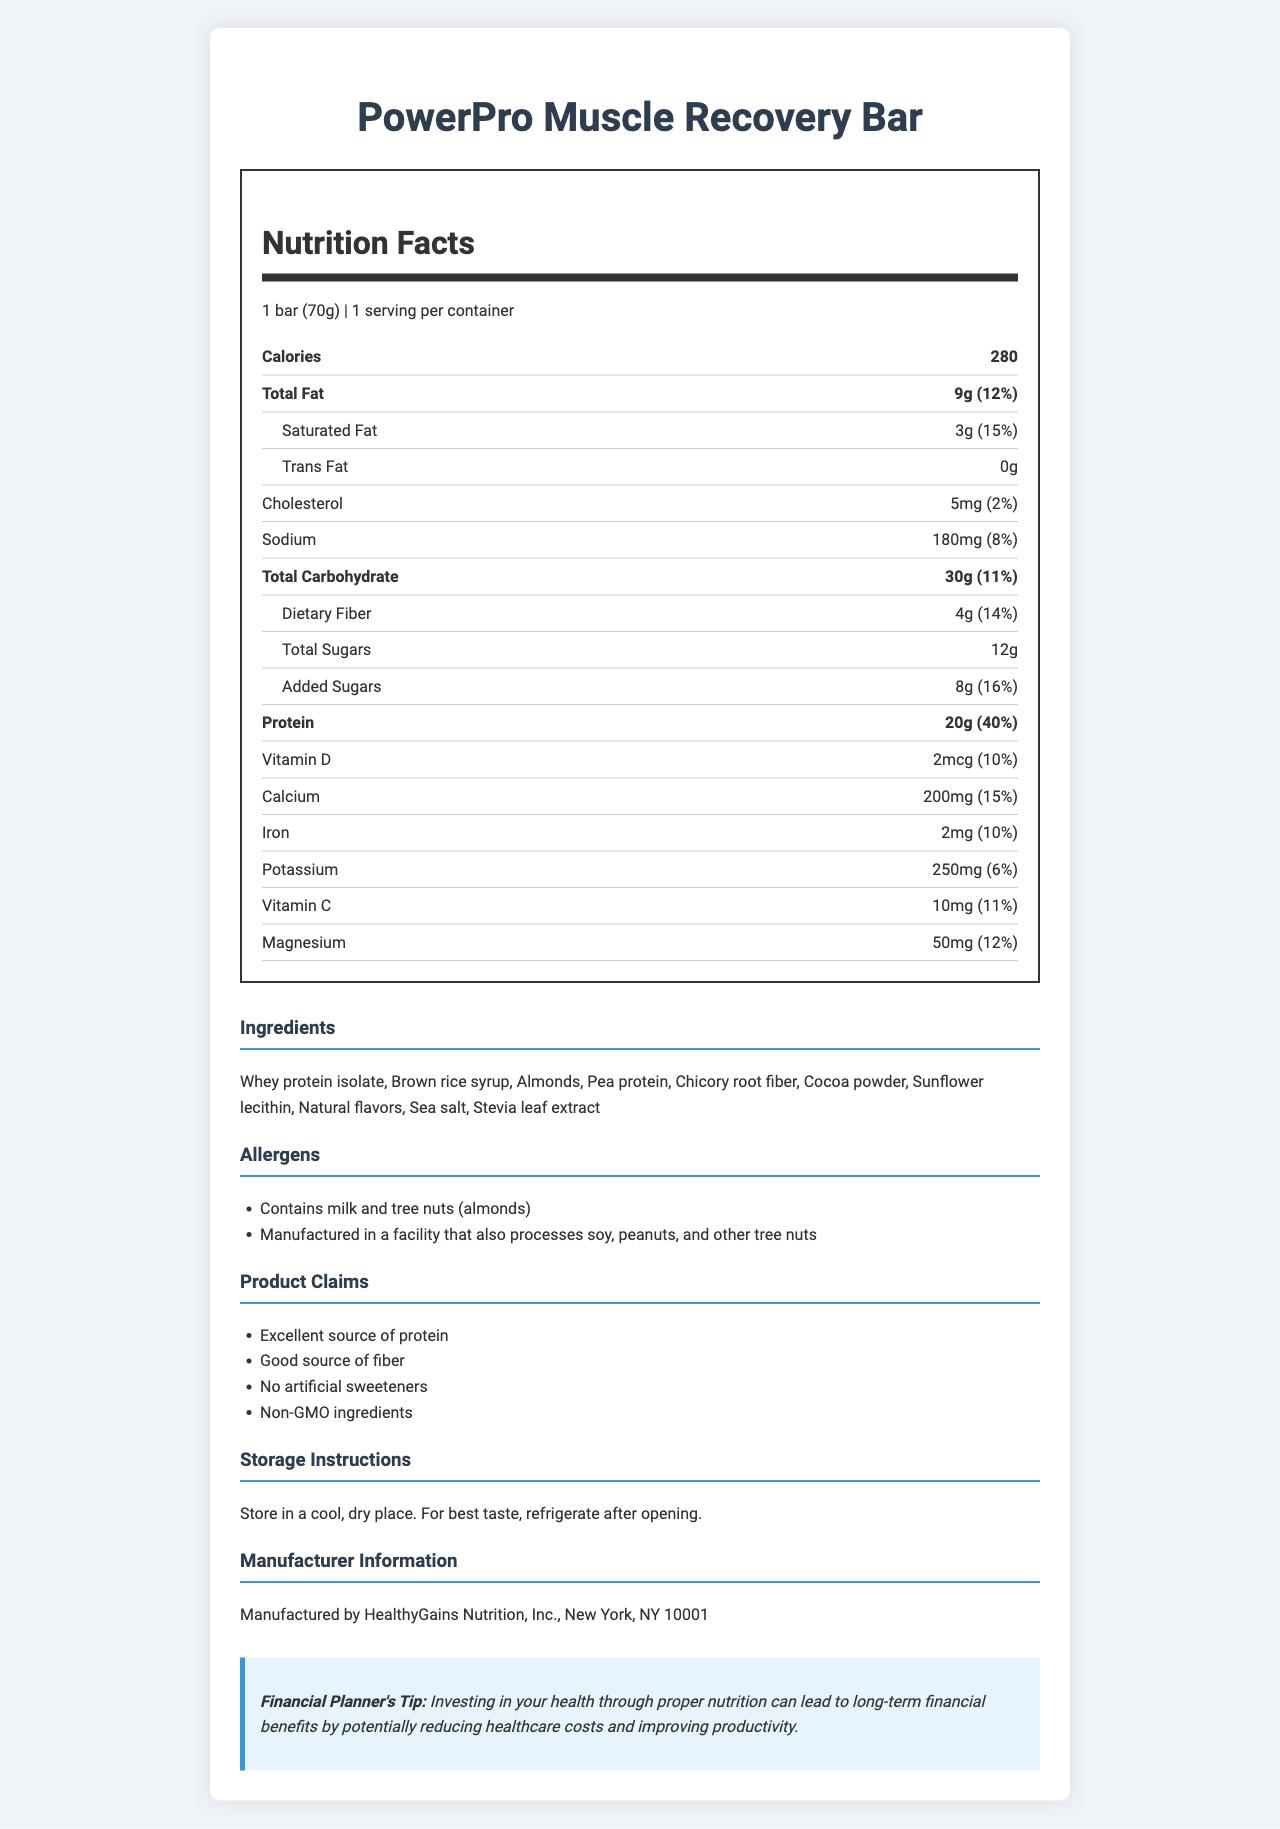what is the serving size of the PowerPro Muscle Recovery Bar? The serving size is listed at the top of the Nutrition Facts Label which states "1 bar (70g)".
Answer: 1 bar (70g) how many grams of protein are in the PowerPro Muscle Recovery Bar? The protein content is listed under the Nutrition Facts section, with "Protein" showing 20 grams.
Answer: 20g what are the claims made by the PowerPro Muscle Recovery Bar? These claims are listed under the "Product Claims" section of the document.
Answer: Excellent source of protein, Good source of fiber, No artificial sweeteners, Non-GMO ingredients what is the daily value percentage of calcium in the PowerPro Muscle Recovery Bar? The calcium daily value percentage is listed under the Nutrition Facts section next to the calcium amount which is 15%.
Answer: 15% how much added sugar does the PowerPro Muscle Recovery Bar contain? The amount of added sugar is listed under the Nutrition Facts section, showing "Added Sugars" as 8 grams.
Answer: 8g what is the total number of calories per serving? The calorie content is prominently listed at the top of the Nutrition Facts Label which states "Calories 280".
Answer: 280 what allergens are present in the PowerPro Muscle Recovery Bar? A. Soy B. Milk C. Peanuts D. Eggs The allergens section lists "Contains milk and tree nuts (almonds)," which includes milk but not soy, peanuts, or eggs.
Answer: B which of the following is not an ingredient in the PowerPro Muscle Recovery Bar? I. Whey protein isolate II. Chicory root fiber III. Artificial sweeteners IV. Almonds The ingredient list includes "Whey protein isolate," "Chicory root fiber," and "Almonds" but specifically mentions "No artificial sweeteners" in the claims.
Answer: III. Artificial sweeteners does the PowerPro Muscle Recovery Bar contain any trans fat? The Nutrition Facts section lists "Trans Fat 0g," indicating there are no trans fats.
Answer: No is PowerPro Muscle Recovery Bar a good source of dietary fiber? The Nutrition Facts section shows that the bar contains 4 grams of dietary fiber, which is 14% of the daily value, and one of the claims is "Good source of fiber."
Answer: Yes summarize the main information found in the document about the PowerPro Muscle Recovery Bar. The document provides detailed nutritional information, ingredient lists, claims, storage instructions, manufacturer details, and a financial tip highlighting the long-term financial benefits of proper nutrition.
Answer: The PowerPro Muscle Recovery Bar is a protein bar designed for post-workout recovery and muscle building, with 280 calories per bar. It provides 20 grams of protein (40% of daily value) and is an excellent source of protein and fiber. The bar has no artificial sweeteners and is made with non-GMO ingredients. Allergens include milk and tree nuts (almonds), and it is manufactured by HealthyGains Nutrition. who manufactures the PowerPro Muscle Recovery Bar? The manufacturer information is clearly listed under the "Manufacturer Information" section of the document.
Answer: HealthyGains Nutrition, Inc., New York, NY 10001 how much cholesterol does the PowerPro Muscle Recovery Bar have? The Nutrition Facts section lists "Cholesterol 5mg," showing the cholesterol amount.
Answer: 5mg what type of certification or guarantee is indicated about the ingredients? Under the claim statements, the bar guarantees "Non-GMO ingredients."
Answer: Non-GMO ingredients how much dietary fiber is in one serving of the PowerPro Muscle Recovery Bar? The Nutrition Facts section lists "Dietary Fiber" and shows an amount of 4 grams.
Answer: 4g does the document provide the recommended retail price of the PowerPro Muscle Recovery Bar? The document does not include any information regarding the price or recommended retail price of the product.
Answer: Cannot be determined 